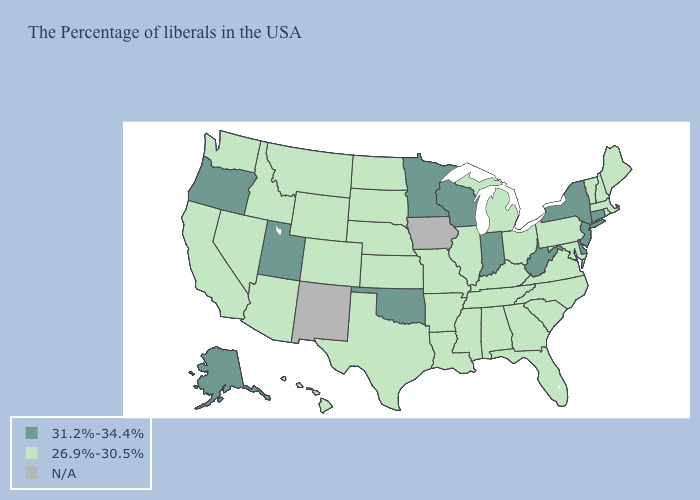How many symbols are there in the legend?
Be succinct. 3. What is the highest value in states that border Iowa?
Write a very short answer. 31.2%-34.4%. Which states have the highest value in the USA?
Quick response, please. Connecticut, New York, New Jersey, Delaware, West Virginia, Indiana, Wisconsin, Minnesota, Oklahoma, Utah, Oregon, Alaska. What is the value of Kentucky?
Short answer required. 26.9%-30.5%. Name the states that have a value in the range 31.2%-34.4%?
Concise answer only. Connecticut, New York, New Jersey, Delaware, West Virginia, Indiana, Wisconsin, Minnesota, Oklahoma, Utah, Oregon, Alaska. Among the states that border Kansas , does Nebraska have the highest value?
Keep it brief. No. Does Minnesota have the lowest value in the USA?
Quick response, please. No. Which states have the lowest value in the Northeast?
Give a very brief answer. Maine, Massachusetts, Rhode Island, New Hampshire, Vermont, Pennsylvania. Name the states that have a value in the range 26.9%-30.5%?
Keep it brief. Maine, Massachusetts, Rhode Island, New Hampshire, Vermont, Maryland, Pennsylvania, Virginia, North Carolina, South Carolina, Ohio, Florida, Georgia, Michigan, Kentucky, Alabama, Tennessee, Illinois, Mississippi, Louisiana, Missouri, Arkansas, Kansas, Nebraska, Texas, South Dakota, North Dakota, Wyoming, Colorado, Montana, Arizona, Idaho, Nevada, California, Washington, Hawaii. What is the lowest value in states that border Maine?
Be succinct. 26.9%-30.5%. What is the lowest value in states that border Pennsylvania?
Be succinct. 26.9%-30.5%. What is the value of Hawaii?
Answer briefly. 26.9%-30.5%. What is the value of Oregon?
Concise answer only. 31.2%-34.4%. 